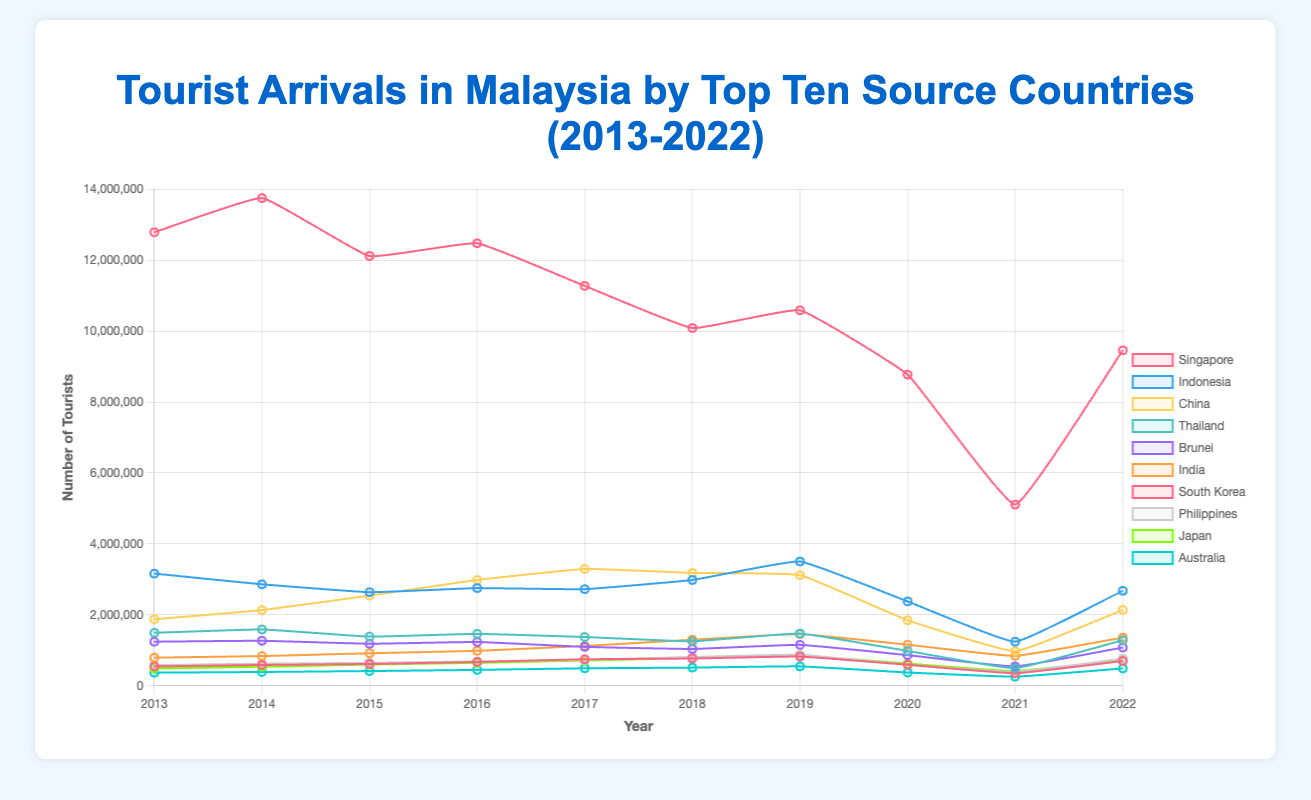What is the trend for tourist arrivals from Singapore over the last decade? Observing the line representing Singapore, it shows a general downward trend from 2013 to 2022, peaking in 2014 and declining significantly around 2019 and beyond, particularly during 2020 and 2021, with slight recovery in 2022.
Answer: General downward trend Which country saw the highest tourist arrivals in 2022? By identifying the peak values of each line for the year 2022, Singapore has the highest number of tourist arrivals.
Answer: Singapore Compare the tourist arrival trends for China and Indonesia over the decade. Who had a higher increase in tourists in the first half of the decade? Analyzing the lines for China and Indonesia, China shows a steeper increase from 2013 to 2017 compared to Indonesia, indicating a higher increase in tourists in the first half of the decade.
Answer: China Which three countries had the most significant drops in tourist arrivals in 2020 compared to 2019? Observing the drops in the height of lines between 2019 and 2020, Singapore, China, and the Philippines have the most significant drops.
Answer: Singapore, China, Philippines On average, how many tourists came from India per year over the last decade? Sum the tourist numbers for India from 2013 to 2022 and divide by 10. The total is (793456 + 837962 + 917534 + 986245 + 1123589 + 1298723 + 1458732 + 1158245 + 843567 + 1358462) = 10620115. Then, 10620115 / 10 = 1062011.5
Answer: 1062011.5 Which country had the least tourist arrivals in 2021? The shortest line height in 2021, which corresponds to the number of tourists, is seen in Australia.
Answer: Australia Compare the total tourist arrivals of Japan and Australia over the entire decade. Who had more visitors? Sum the tourist numbers for Japan (489346 + 537286 + 598435 + 648347 + 713569 + 782345 + 856734 + 625498 + 413587 + 734865) and Australia (370498 + 389735 + 415796 + 448297 + 493782 + 512358 + 547623 + 375382 + 257632 + 489273). Japan’s total is 6403012, and Australia’s total is 4205376, so Japan had more.
Answer: Japan Which country had relatively stable tourist arrival numbers without significant drops or spikes over the decade? Comparing the fluctuation patterns in each line, Brunei shows relatively stable tourist arrival numbers with no significant drops or spikes.
Answer: Brunei What is the difference in the number of tourists between Thailand and the Philippines in 2022? Subtract the number of tourists from the Philippines in 2022 from those in Thailand: 1285763 - 765389 = 520374.
Answer: 520374 